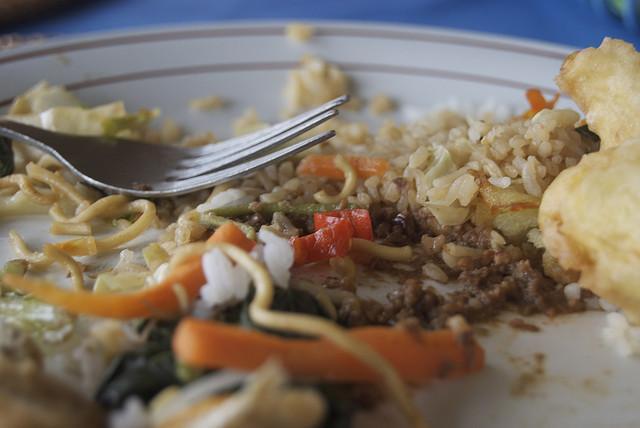How many carrots are there?
Give a very brief answer. 2. 